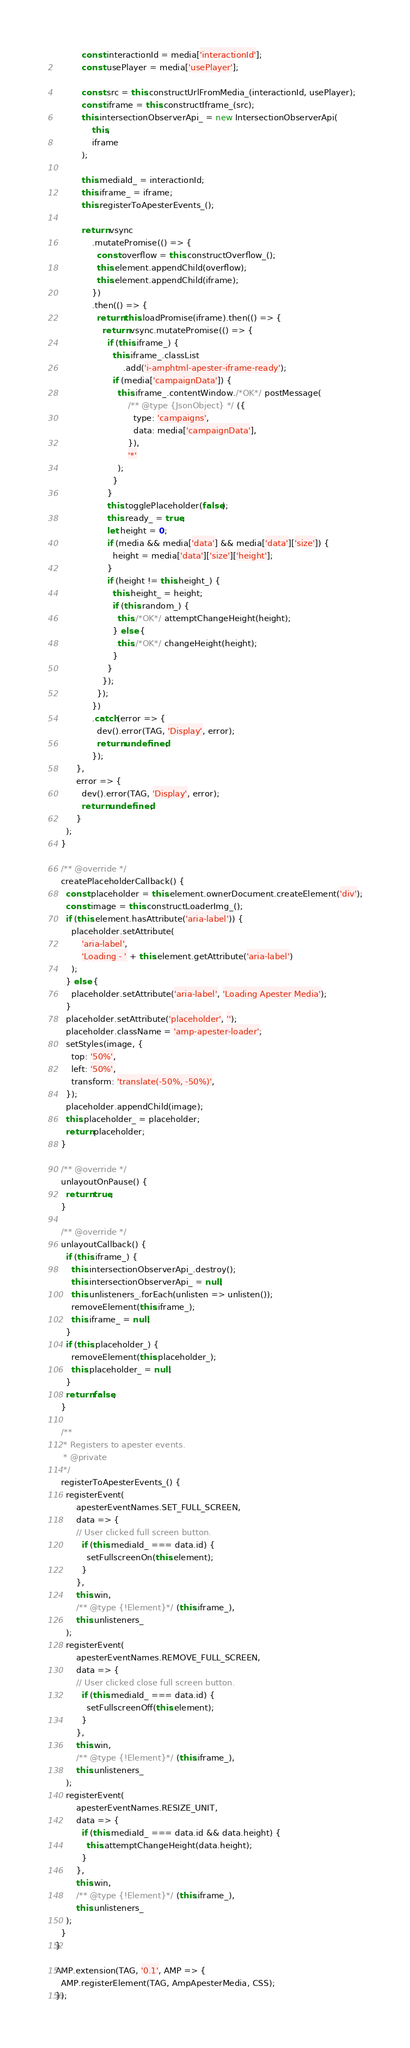<code> <loc_0><loc_0><loc_500><loc_500><_JavaScript_>
          const interactionId = media['interactionId'];
          const usePlayer = media['usePlayer'];

          const src = this.constructUrlFromMedia_(interactionId, usePlayer);
          const iframe = this.constructIframe_(src);
          this.intersectionObserverApi_ = new IntersectionObserverApi(
              this,
              iframe
          );

          this.mediaId_ = interactionId;
          this.iframe_ = iframe;
          this.registerToApesterEvents_();

          return vsync
              .mutatePromise(() => {
                const overflow = this.constructOverflow_();
                this.element.appendChild(overflow);
                this.element.appendChild(iframe);
              })
              .then(() => {
                return this.loadPromise(iframe).then(() => {
                  return vsync.mutatePromise(() => {
                    if (this.iframe_) {
                      this.iframe_.classList
                          .add('i-amphtml-apester-iframe-ready');
                      if (media['campaignData']) {
                        this.iframe_.contentWindow./*OK*/ postMessage(
                            /** @type {JsonObject} */ ({
                              type: 'campaigns',
                              data: media['campaignData'],
                            }),
                            '*'
                        );
                      }
                    }
                    this.togglePlaceholder(false);
                    this.ready_ = true;
                    let height = 0;
                    if (media && media['data'] && media['data']['size']) {
                      height = media['data']['size']['height'];
                    }
                    if (height != this.height_) {
                      this.height_ = height;
                      if (this.random_) {
                        this./*OK*/ attemptChangeHeight(height);
                      } else {
                        this./*OK*/ changeHeight(height);
                      }
                    }
                  });
                });
              })
              .catch(error => {
                dev().error(TAG, 'Display', error);
                return undefined;
              });
        },
        error => {
          dev().error(TAG, 'Display', error);
          return undefined;
        }
    );
  }

  /** @override */
  createPlaceholderCallback() {
    const placeholder = this.element.ownerDocument.createElement('div');
    const image = this.constructLoaderImg_();
    if (this.element.hasAttribute('aria-label')) {
      placeholder.setAttribute(
          'aria-label',
          'Loading - ' + this.element.getAttribute('aria-label')
      );
    } else {
      placeholder.setAttribute('aria-label', 'Loading Apester Media');
    }
    placeholder.setAttribute('placeholder', '');
    placeholder.className = 'amp-apester-loader';
    setStyles(image, {
      top: '50%',
      left: '50%',
      transform: 'translate(-50%, -50%)',
    });
    placeholder.appendChild(image);
    this.placeholder_ = placeholder;
    return placeholder;
  }

  /** @override */
  unlayoutOnPause() {
    return true;
  }

  /** @override */
  unlayoutCallback() {
    if (this.iframe_) {
      this.intersectionObserverApi_.destroy();
      this.intersectionObserverApi_ = null;
      this.unlisteners_.forEach(unlisten => unlisten());
      removeElement(this.iframe_);
      this.iframe_ = null;
    }
    if (this.placeholder_) {
      removeElement(this.placeholder_);
      this.placeholder_ = null;
    }
    return false;
  }

  /**
   * Registers to apester events.
   * @private
   */
  registerToApesterEvents_() {
    registerEvent(
        apesterEventNames.SET_FULL_SCREEN,
        data => {
        // User clicked full screen button.
          if (this.mediaId_ === data.id) {
            setFullscreenOn(this.element);
          }
        },
        this.win,
        /** @type {!Element}*/ (this.iframe_),
        this.unlisteners_
    );
    registerEvent(
        apesterEventNames.REMOVE_FULL_SCREEN,
        data => {
        // User clicked close full screen button.
          if (this.mediaId_ === data.id) {
            setFullscreenOff(this.element);
          }
        },
        this.win,
        /** @type {!Element}*/ (this.iframe_),
        this.unlisteners_
    );
    registerEvent(
        apesterEventNames.RESIZE_UNIT,
        data => {
          if (this.mediaId_ === data.id && data.height) {
            this.attemptChangeHeight(data.height);
          }
        },
        this.win,
        /** @type {!Element}*/ (this.iframe_),
        this.unlisteners_
    );
  }
}

AMP.extension(TAG, '0.1', AMP => {
  AMP.registerElement(TAG, AmpApesterMedia, CSS);
});
</code> 